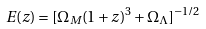Convert formula to latex. <formula><loc_0><loc_0><loc_500><loc_500>E ( z ) = [ \Omega _ { M } ( 1 + z ) ^ { 3 } + \Omega _ { \Lambda } ] ^ { - 1 / 2 }</formula> 